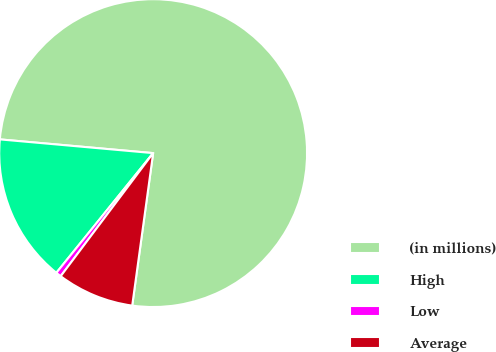Convert chart to OTSL. <chart><loc_0><loc_0><loc_500><loc_500><pie_chart><fcel>(in millions)<fcel>High<fcel>Low<fcel>Average<nl><fcel>75.75%<fcel>15.6%<fcel>0.57%<fcel>8.08%<nl></chart> 